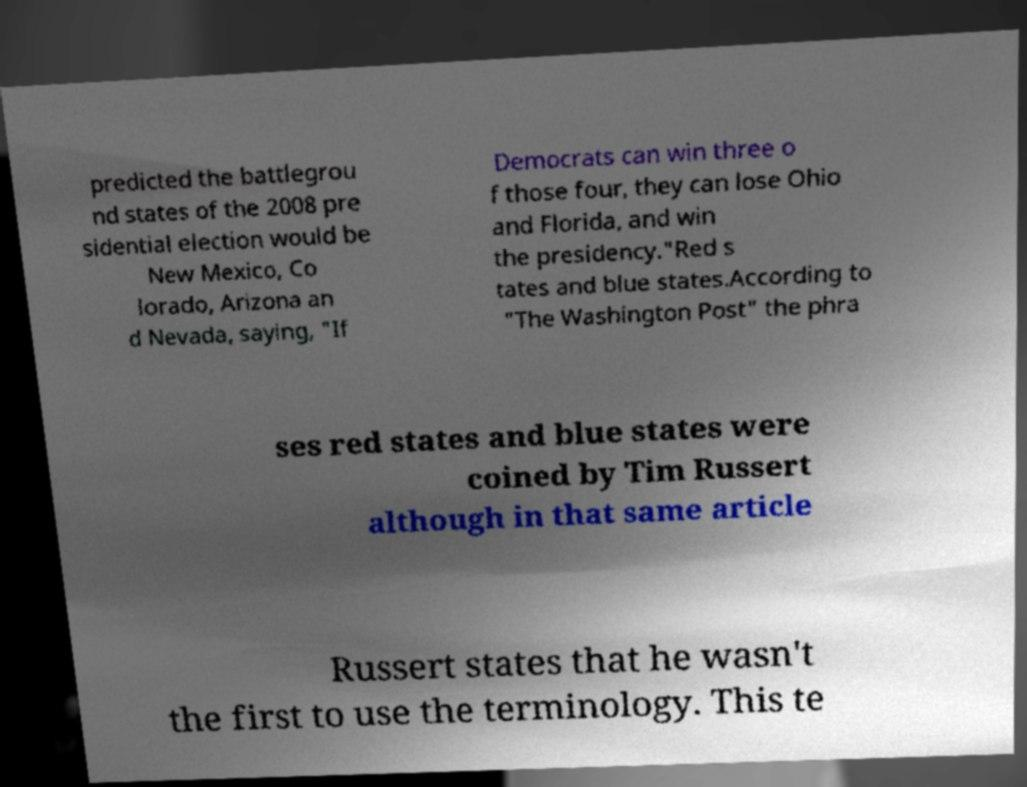Could you extract and type out the text from this image? predicted the battlegrou nd states of the 2008 pre sidential election would be New Mexico, Co lorado, Arizona an d Nevada, saying, "If Democrats can win three o f those four, they can lose Ohio and Florida, and win the presidency."Red s tates and blue states.According to "The Washington Post" the phra ses red states and blue states were coined by Tim Russert although in that same article Russert states that he wasn't the first to use the terminology. This te 